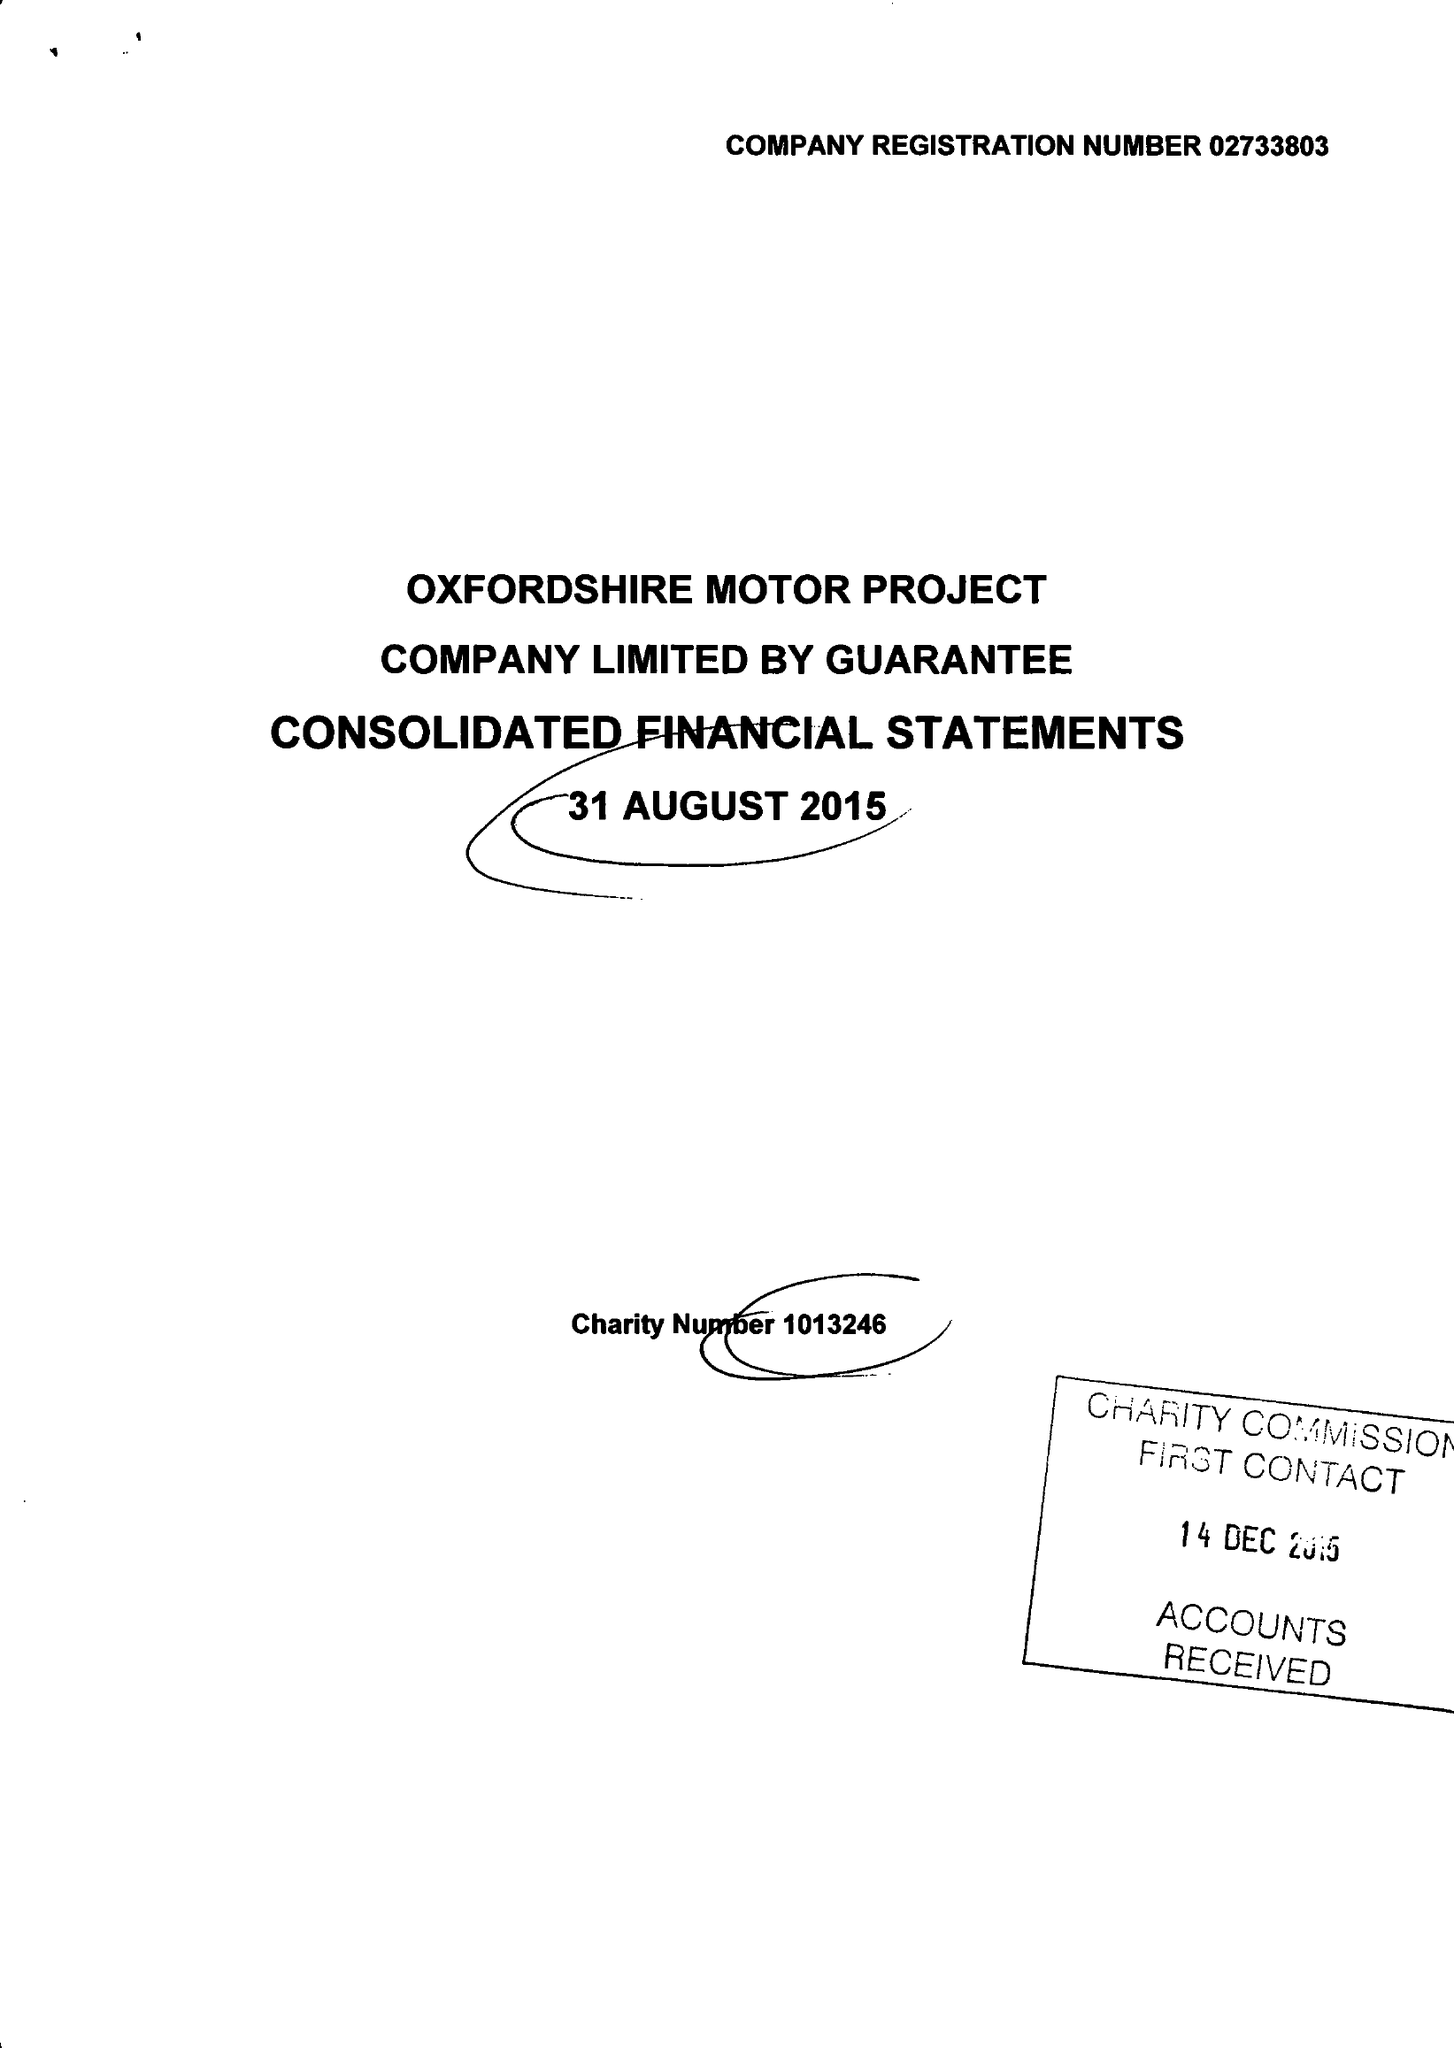What is the value for the address__postcode?
Answer the question using a single word or phrase. OX2 8JR 